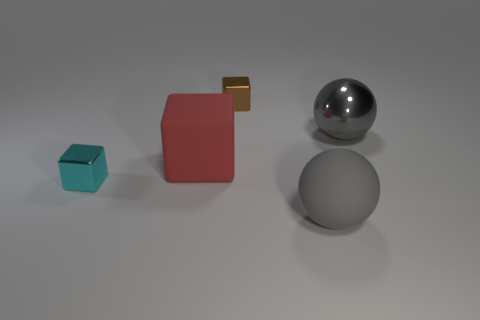What number of red things are the same shape as the small brown thing?
Provide a succinct answer. 1. Is the large gray metal object the same shape as the big gray rubber thing?
Your answer should be very brief. Yes. What size is the cyan shiny object?
Offer a terse response. Small. How many red objects have the same size as the metal sphere?
Your answer should be very brief. 1. Is the size of the shiny thing right of the small brown cube the same as the matte object that is behind the cyan shiny block?
Provide a short and direct response. Yes. The big matte object that is to the left of the brown thing has what shape?
Your response must be concise. Cube. What is the material of the big thing behind the matte object on the left side of the brown block?
Your answer should be compact. Metal. Are there any other spheres of the same color as the metallic sphere?
Your answer should be compact. Yes. There is a cyan metal object; is its size the same as the metal block to the right of the tiny cyan shiny thing?
Make the answer very short. Yes. How many large gray metal balls are behind the sphere that is behind the sphere that is in front of the small cyan metallic block?
Your response must be concise. 0. 